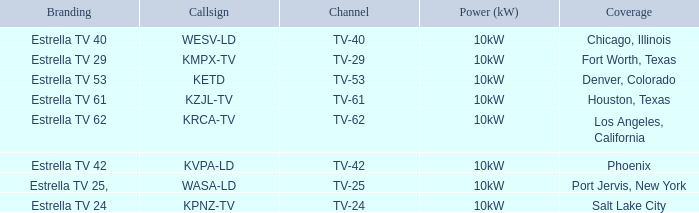List the branding for krca-tv. Estrella TV 62. 